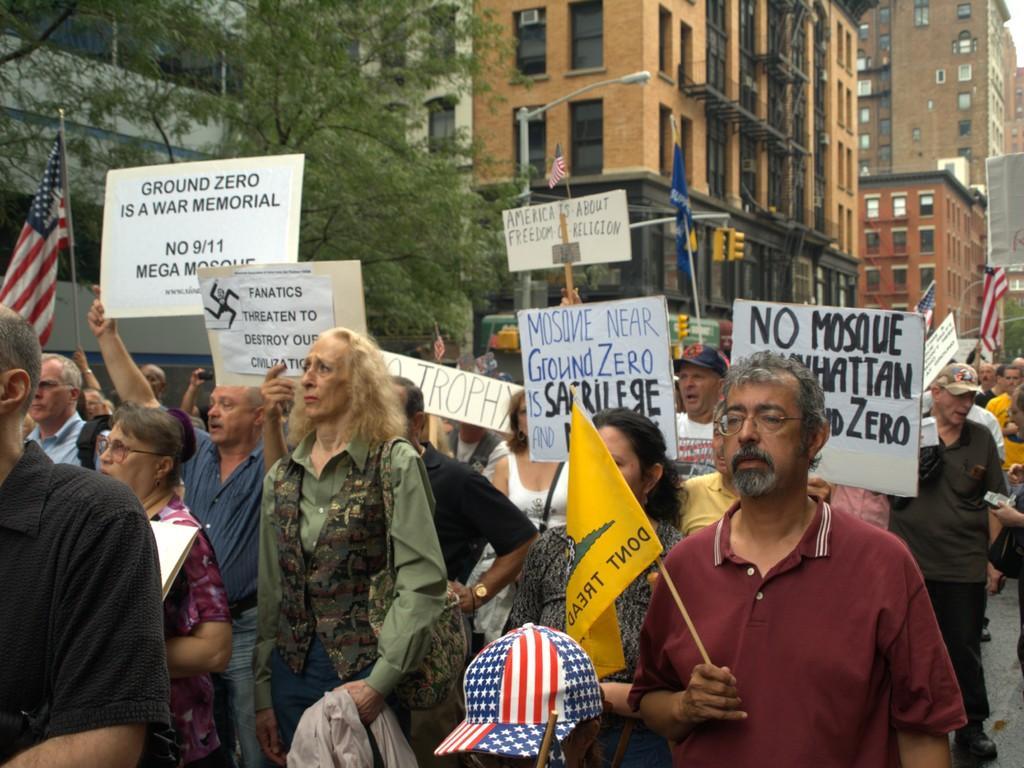Could you give a brief overview of what you see in this image? This is an outside view. Here I can see a crowd of people holding boards and flags in the hands and walking on the road towards the left side. In the background there are many buildings and trees. On the boards, I can see the text. 